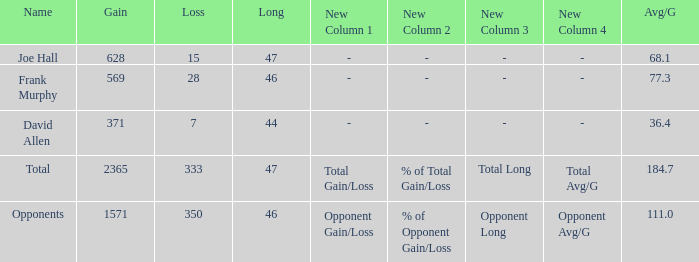How much Avg/G has a Gain smaller than 1571, and a Long smaller than 46? 1.0. 